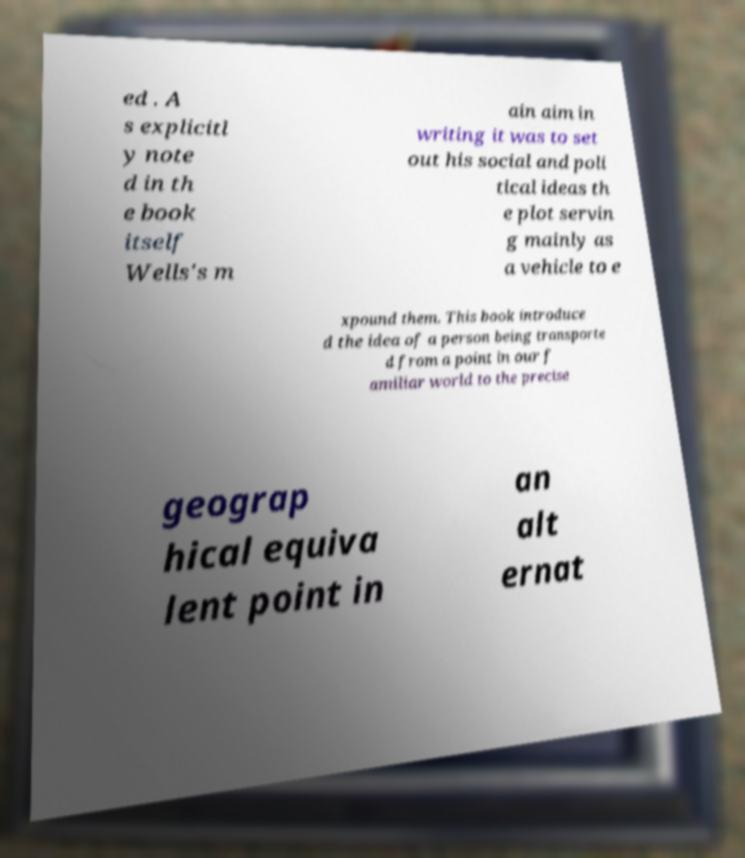For documentation purposes, I need the text within this image transcribed. Could you provide that? ed . A s explicitl y note d in th e book itself Wells's m ain aim in writing it was to set out his social and poli tical ideas th e plot servin g mainly as a vehicle to e xpound them. This book introduce d the idea of a person being transporte d from a point in our f amiliar world to the precise geograp hical equiva lent point in an alt ernat 